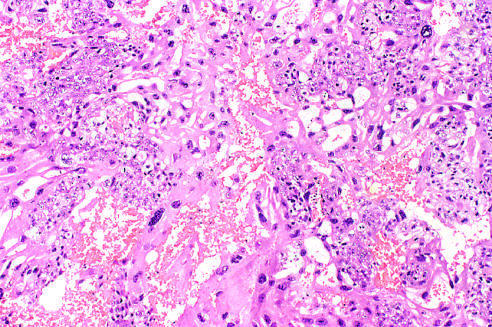what contains both neoplastic cytotro-phoblast and multinucleate syncytiotrophoblast?
Answer the question using a single word or phrase. The field 